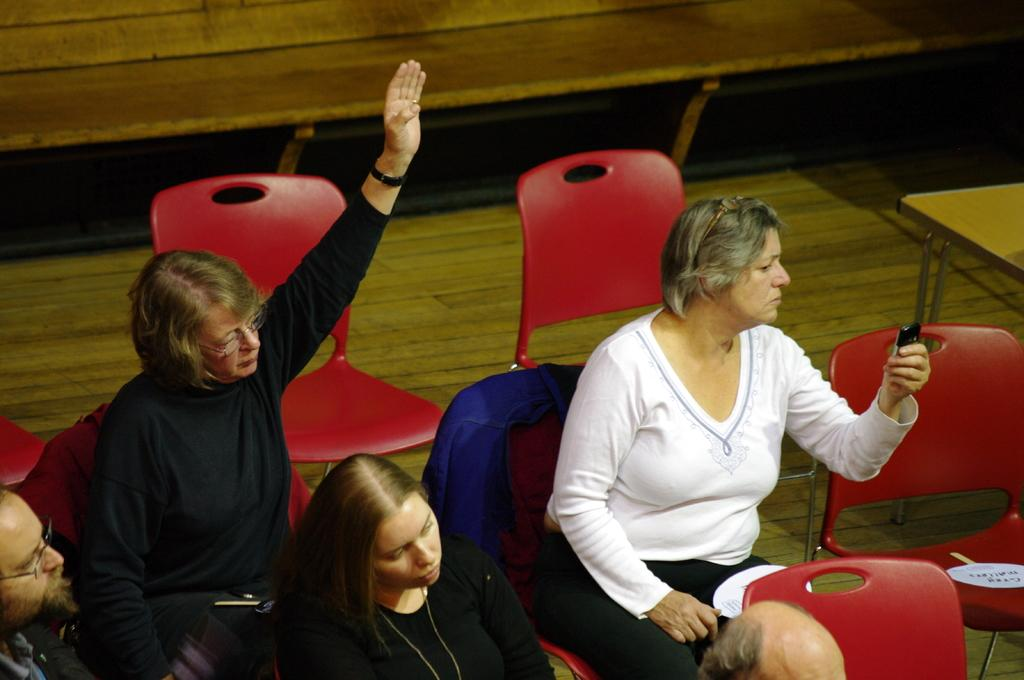What are the people in the center of the image doing? The people in the center of the image are sitting on chairs. What is the person on the right side of the image doing? The person on the right side of the image is holding a phone. What can be seen in the background of the image? There is a wall, a table, and chairs in the background of the image. What type of pest can be seen crawling on the table in the image? There is no pest visible on the table in the image. What is the rate at which the people are sitting on the chairs in the image? The rate at which the people are sitting on the chairs cannot be determined from the image. 